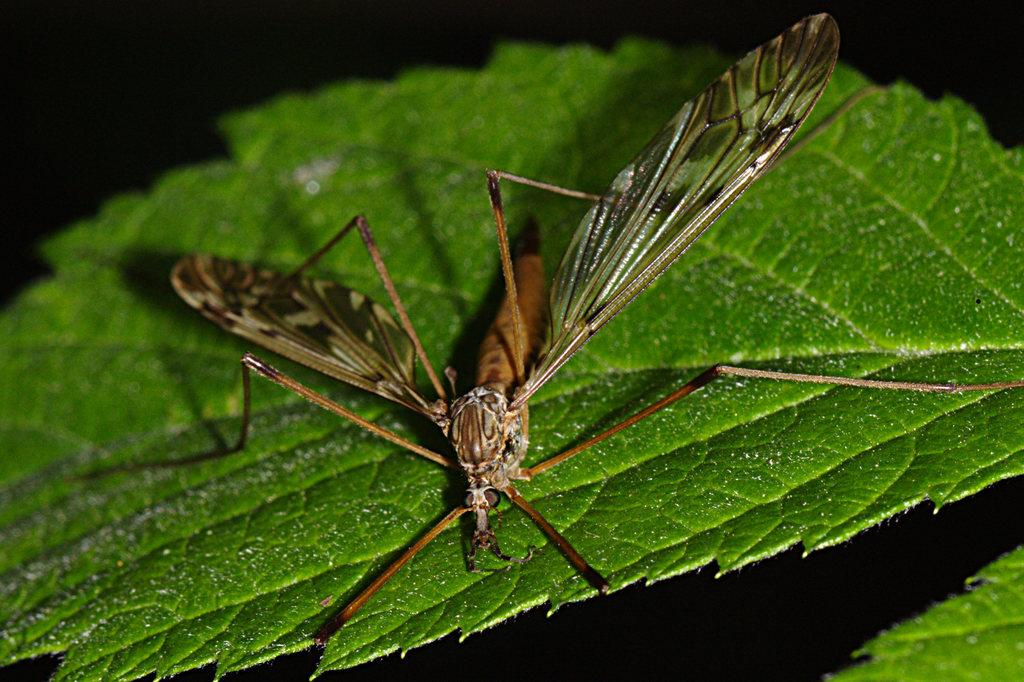What is present in the image? There is an insect in the image. Where is the insect located? The insect is on a leaf. Can you describe the position of the insect in the image? The insect is in the middle of the image. What type of cart can be seen in the image? There is no cart present in the image; it features an insect on a leaf. What muscle is being exercised by the insect in the image? Insects do not have muscles like humans, and there is no indication of any muscle activity in the image. 